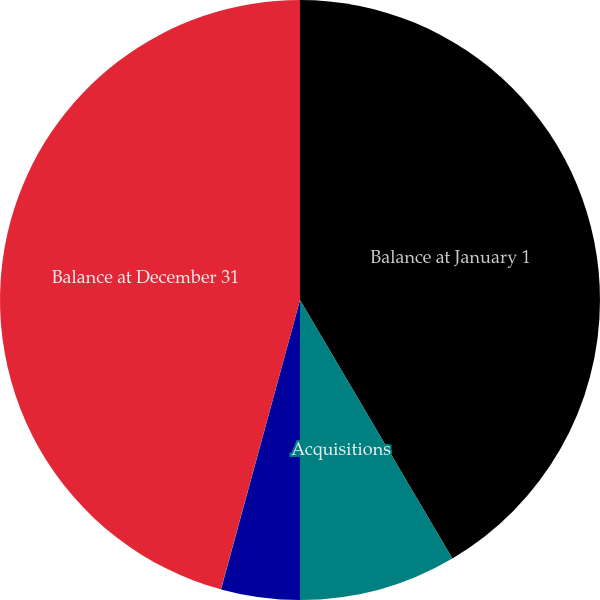Convert chart to OTSL. <chart><loc_0><loc_0><loc_500><loc_500><pie_chart><fcel>Balance at January 1<fcel>Acquisitions<fcel>DVA Renal Healthcare income<fcel>Divestitures and other<fcel>Balance at December 31<nl><fcel>41.52%<fcel>8.48%<fcel>4.24%<fcel>0.01%<fcel>45.75%<nl></chart> 